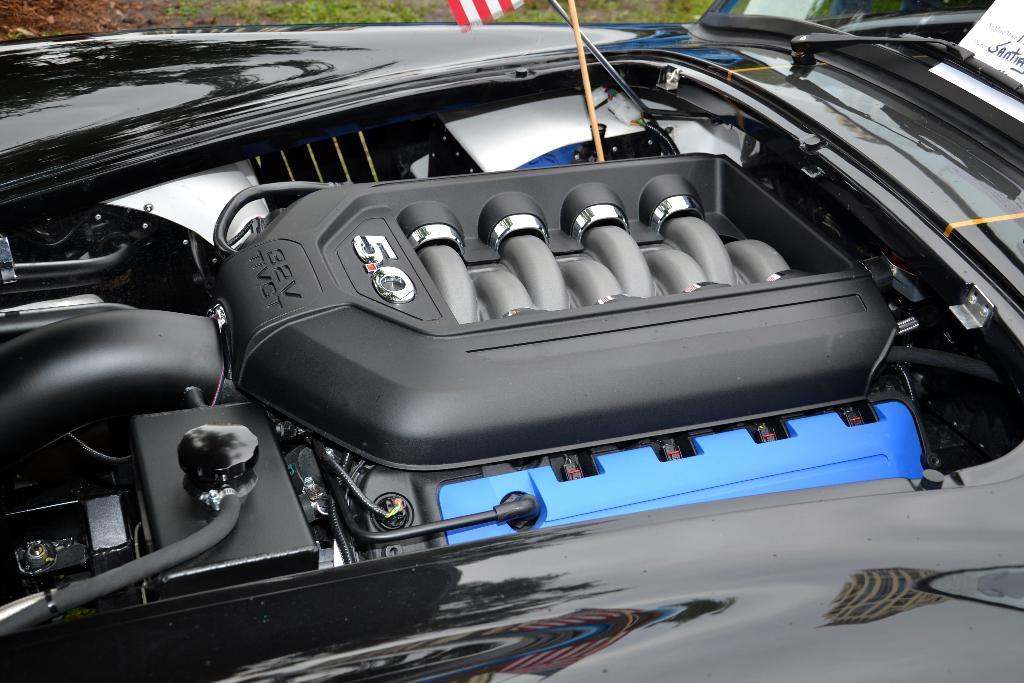What is the main subject in the foreground of the image? There is an engine of a black car in the foreground of the image. What type of vegetation can be seen at the top of the image? There are grasses visible at the top of the image. How many eyes can be seen on the engine in the image? There are no eyes present on the engine in the image, as engines are inanimate objects and do not have eyes. 